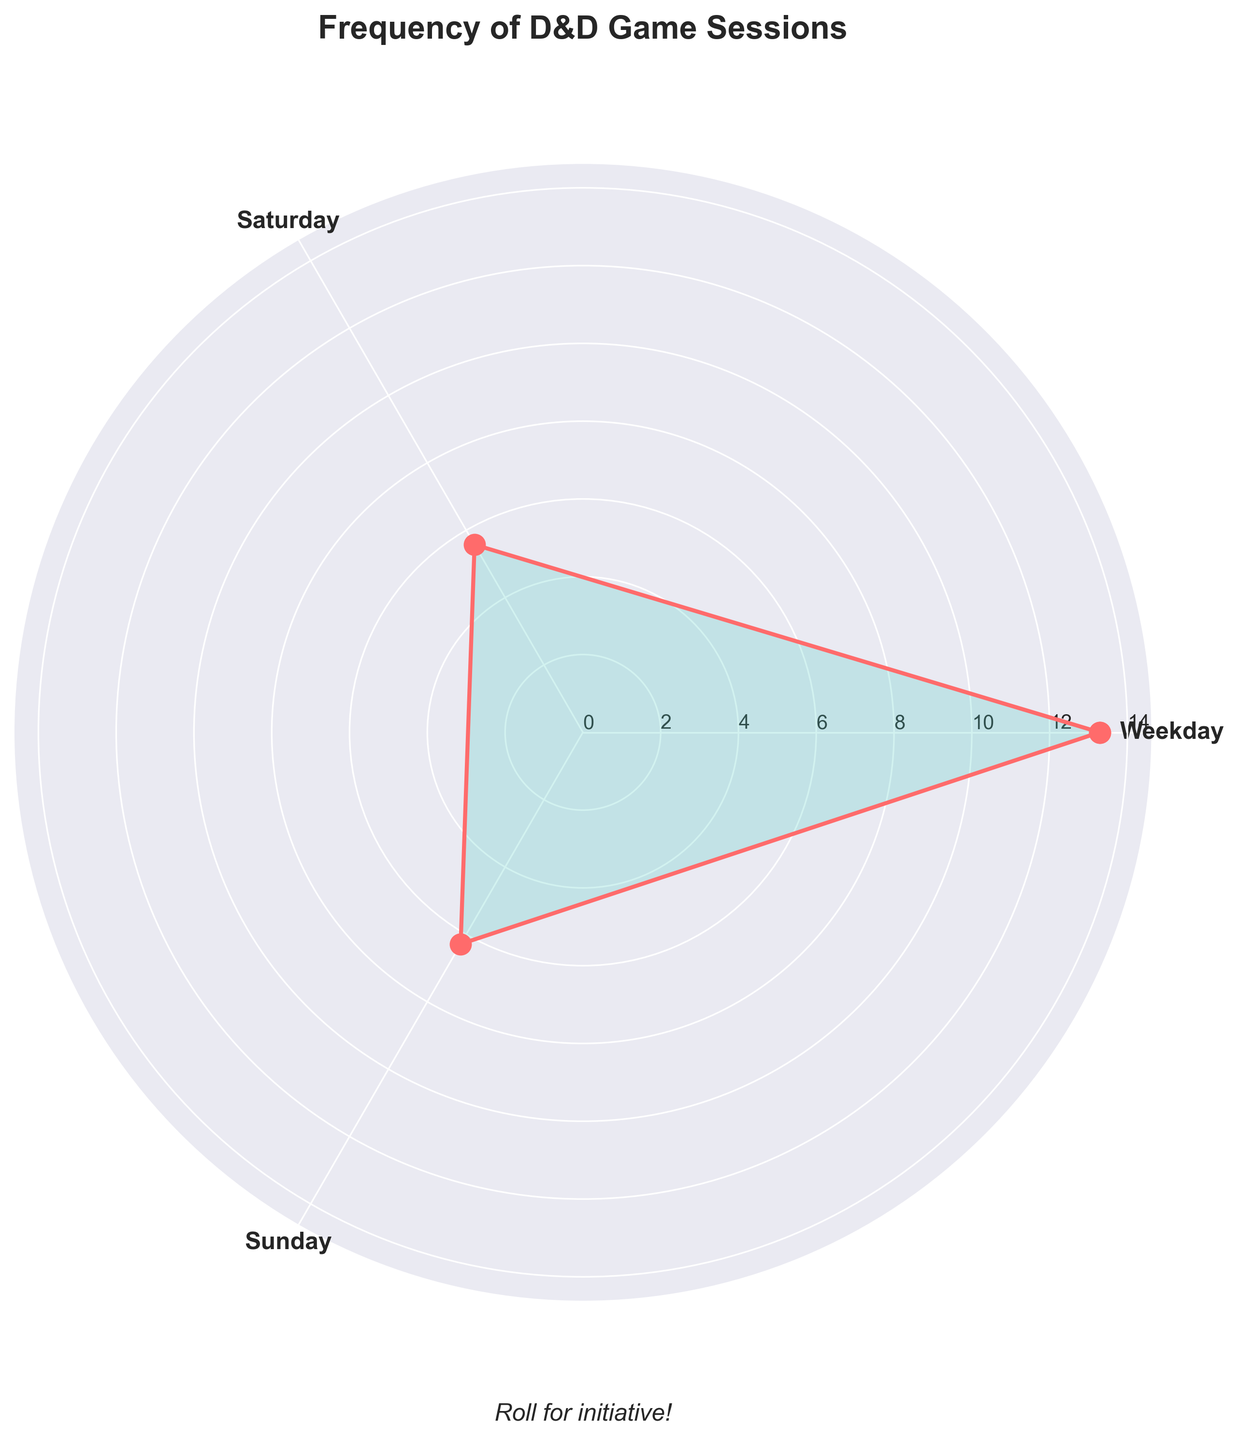What does the title of the rose chart say? The title is usually placed at the top of the chart and provides a brief description of what the chart is about. In this case, the title is clearly visible.
Answer: Frequency of D&D Game Sessions How many groups are shown in the rose chart? By looking at the plot, we can identify the distinct number of labeled sections. Each label represents a group.
Answer: Three On which day is the frequency of game sessions the highest on average? The rose chart uses angles and the length of the plotted lines to depict values. The angle with the longest line indicates the highest value.
Answer: Sunday How do the game session frequencies on weekdays compare to Sundays? By comparing the radial lengths corresponding to each group, we can see which day has longer bars. Combine the information to see that Weekdays have a generally higher bar compared to Sundays.
Answer: Weekdays have a slightly lower average frequency compared to Sundays What is the average frequency of game sessions on Saturdays and Sundays combined? Calculate the average for Saturdays and Sundays from the data provided, then take the mean of these two averages. From the data: average on Saturday = (5+6+4+7+6+5+6)/7 = 5.57, average on Sunday = (6+7+5+8+5+7+6)/7 = 6.29, then calculate mean of these two: (5.57 + 6.29) / 2.
Answer: 5.93 Which day of the week shows the most variability in game session frequencies? Variability can be assessed by comparing the spread of the data points visually. The chart representations show the range of values, and wider ranges suggest more variability.
Answer: Weekdays Looking at the rose chart, how does the frequency of game sessions on Saturdays compare to weekdays? By examining the lengths of bars for both categories and comparing them visually, weekdays have longer lines (higher frequencies) than Saturdays.
Answer: Frequencies are higher on weekdays than on Saturdays Which group has the smallest average frequency of game sessions? Identify the shortest average bar from the rose chart. The shortest segment corresponds to the group with the smallest average frequency.
Answer: Saturday Explain the relationship between weekdays and Saturdays in terms of game session frequencies. Comparing weekdays and Saturdays visually shows that frequencies on weekdays are predominantly higher than on Saturdays. This indicates players prefer weekdays more frequently compared to Saturdays.
Answer: Weekdays have higher frequencies than Saturdays What pattern or trend can be noted in the frequency of game sessions throughout the week? The rose chart can reveal the pattern by showing increasing or decreasing trends in the frequencies. By observing that weekdays and Sundays have higher frequency bars than Saturdays, we see a trend where weekends have moderate participation with a higher bump on Sundays.
Answer: There's a dip on Saturdays and a rise on Sundays 